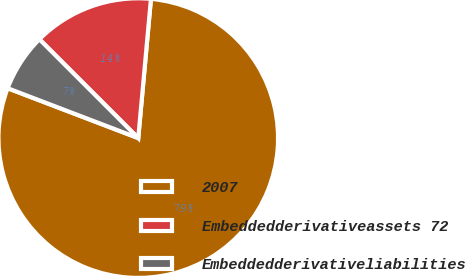Convert chart. <chart><loc_0><loc_0><loc_500><loc_500><pie_chart><fcel>2007<fcel>Embeddedderivativeassets 72<fcel>Embeddedderivativeliabilities<nl><fcel>79.36%<fcel>13.95%<fcel>6.69%<nl></chart> 